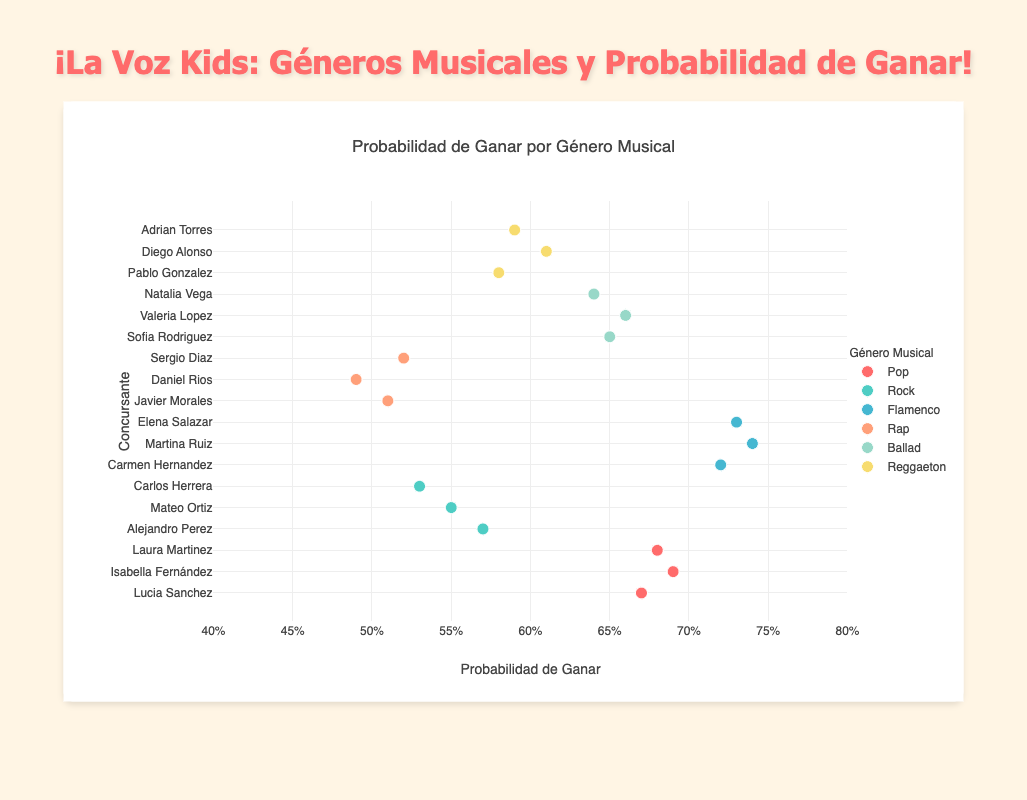What's the title of the scatter plot? The title is located at the top of the figure, as a header in a larger font size than other texts. It summarizes what the figure is about.
Answer: Probabilidad de Ganar por Género Musical What is the average winning probability for contestants performing Flamenco? The winning probabilities for Flamenco are 0.72, 0.74, and 0.73. Adding these and dividing by 3 gives: (0.72 + 0.74 + 0.73) / 3 = 2.19 / 3 = 0.73.
Answer: 0.73 Which genre has the contestant with the highest winning probability? The highest winning probability on the x-axis is 0.74, belonging to a Flamenco contestant judging from the color and the hover information.
Answer: Flamenco How many contestants performed Ballads? Look for all markers with the same color representing Ballads. There are 3 such markers.
Answer: 3 What is the difference in winning probability between the highest and lowest performing contestants in the Rap genre? Identify the highest and lowest probabilities for Rap, which are 0.52 and 0.49. The difference is 0.52 - 0.49 = 0.03.
Answer: 0.03 Which contestant has the highest winning probability in the Pop genre? From the hover information, find the contestant with the highest x-value in the Pop genre. Isabella Fernández with 0.69 has the highest probability.
Answer: Isabella Fernández Does any genre have a consistent winning probability higher than 0.65? Check each genre to see if all its points are above 0.65. Only Flamenco has all probabilities (0.72, 0.74, 0.73) consistently higher than 0.65.
Answer: Flamenco Compare the winning probabilities for contestants performing Pop vs. Rock. Which genre has a higher average winning probability? Calculate the average for Pop (0.67, 0.69, 0.68) which is (0.67 + 0.69 + 0.68) / 3 = 0.68. For Rock (0.57, 0.55, 0.53), it is (0.57 + 0.55 + 0.53) / 3 = 0.55. Pop has a higher average.
Answer: Pop Which genres have contestants with winning probabilities below 0.60? Identify markers with x-values below 0.60 and their associated genres. The genres are Rock (0.57, 0.55, 0.53), Rap (0.51, 0.49, 0.52), and Reggaeton (0.58, 0.59).
Answer: Rock, Rap, Reggaeton 